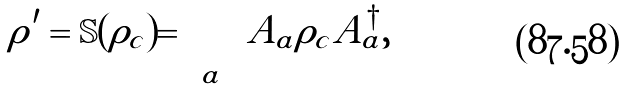Convert formula to latex. <formula><loc_0><loc_0><loc_500><loc_500>\rho ^ { \prime } = \mathbb { S } ( \rho _ { c } ) = \sum _ { a } A _ { a } \rho _ { c } A _ { a } ^ { \dagger } ,</formula> 